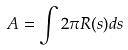<formula> <loc_0><loc_0><loc_500><loc_500>A = \int 2 \pi R ( s ) d s</formula> 